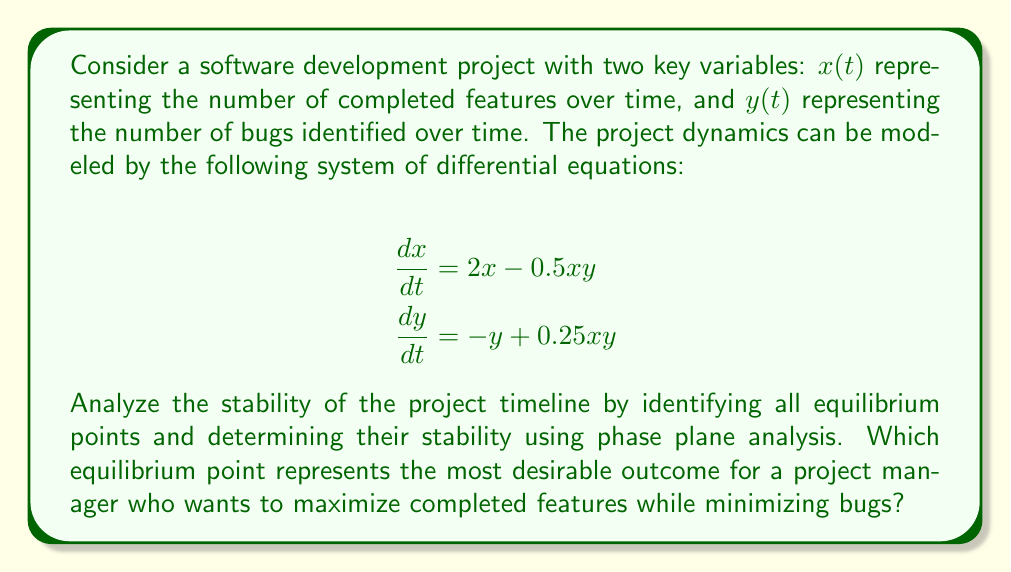Can you solve this math problem? 1. Find the equilibrium points by setting $\frac{dx}{dt} = 0$ and $\frac{dy}{dt} = 0$:

   $2x - 0.5xy = 0$
   $-y + 0.25xy = 0$

2. Solve the system:
   a) From the first equation: $x(2 - 0.5y) = 0$, so $x = 0$ or $y = 4$
   b) From the second equation: $y(-1 + 0.25x) = 0$, so $y = 0$ or $x = 4$

   This gives us three equilibrium points: $(0,0)$, $(4,4)$, and $(4,0)$

3. Analyze stability using the Jacobian matrix:

   $$J = \begin{bmatrix}
   \frac{\partial}{\partial x}(2x - 0.5xy) & \frac{\partial}{\partial y}(2x - 0.5xy) \\
   \frac{\partial}{\partial x}(-y + 0.25xy) & \frac{\partial}{\partial y}(-y + 0.25xy)
   \end{bmatrix} = \begin{bmatrix}
   2 - 0.5y & -0.5x \\
   0.25y & -1 + 0.25x
   \end{bmatrix}$$

4. Evaluate the Jacobian at each equilibrium point:

   a) At $(0,0)$: $J_{(0,0)} = \begin{bmatrix} 2 & 0 \\ 0 & -1 \end{bmatrix}$
      Eigenvalues: $\lambda_1 = 2$, $\lambda_2 = -1$
      This is an unstable saddle point.

   b) At $(4,4)$: $J_{(4,4)} = \begin{bmatrix} 0 & -2 \\ 1 & 0 \end{bmatrix}$
      Eigenvalues: $\lambda_{1,2} = \pm i$
      This is a center (neutrally stable).

   c) At $(4,0)$: $J_{(4,0)} = \begin{bmatrix} 2 & -2 \\ 0 & 0 \end{bmatrix}$
      Eigenvalues: $\lambda_1 = 2$, $\lambda_2 = 0$
      This is a non-hyperbolic equilibrium point (unstable).

5. Interpret the results:
   - $(0,0)$ represents no progress (unstable)
   - $(4,4)$ represents a balanced state with equal features and bugs (neutrally stable)
   - $(4,0)$ represents maximum features with no bugs (unstable, but desirable)

6. For a project manager, the most desirable outcome is $(4,0)$, which maximizes completed features (x) while minimizing bugs (y). Although unstable, this point represents the ideal project state.
Answer: $(4,0)$ - maximum features, no bugs (unstable equilibrium) 